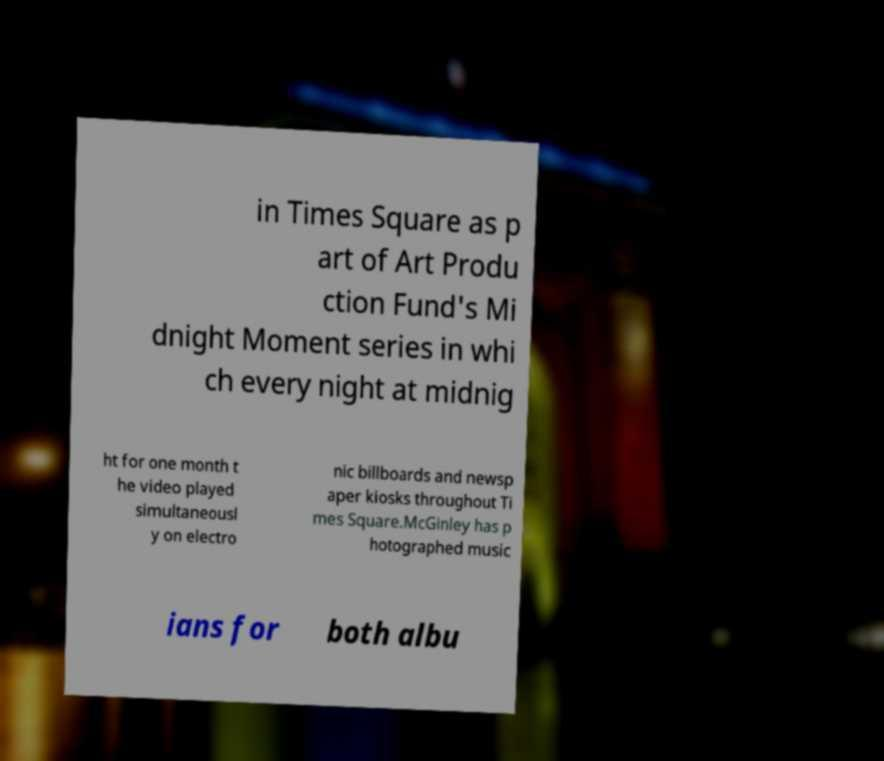Could you assist in decoding the text presented in this image and type it out clearly? in Times Square as p art of Art Produ ction Fund's Mi dnight Moment series in whi ch every night at midnig ht for one month t he video played simultaneousl y on electro nic billboards and newsp aper kiosks throughout Ti mes Square.McGinley has p hotographed music ians for both albu 